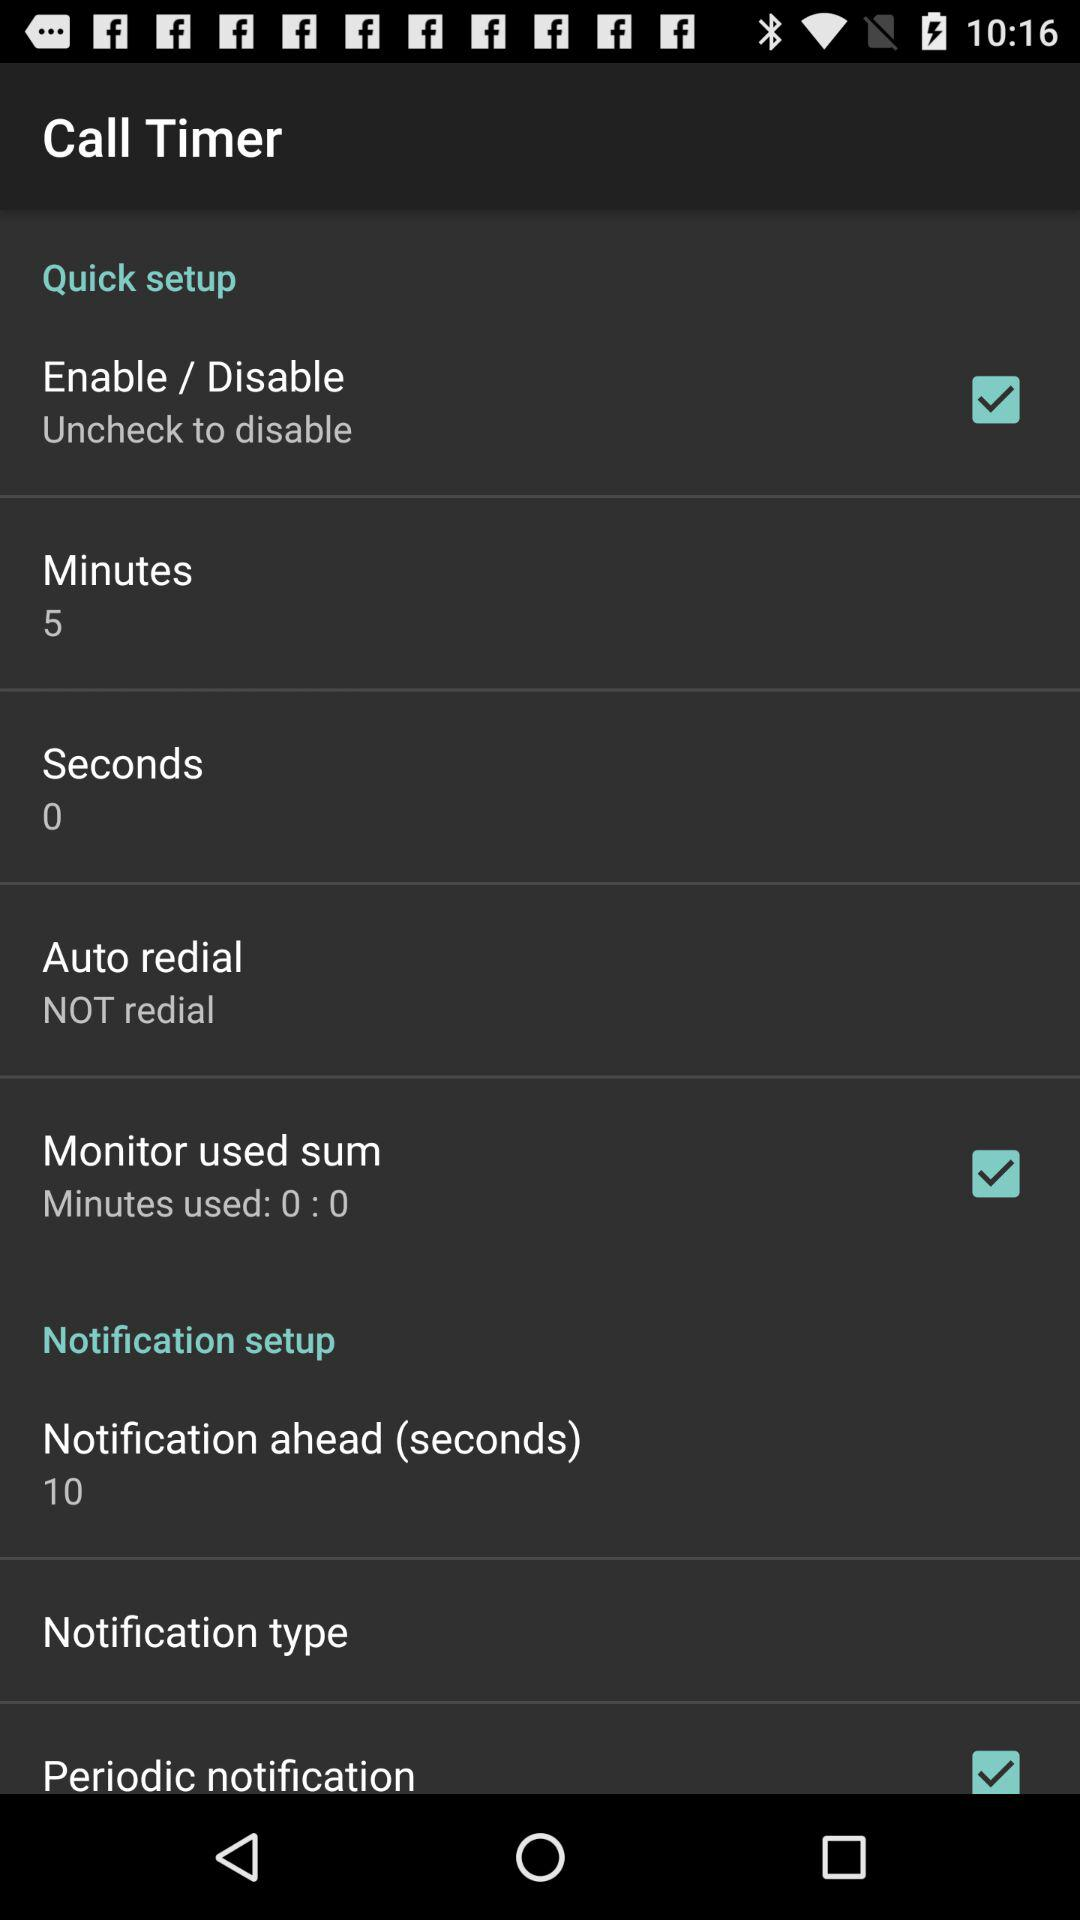What is the duration of "Notification ahead"? The duration of "Notification ahead" is 10 seconds. 